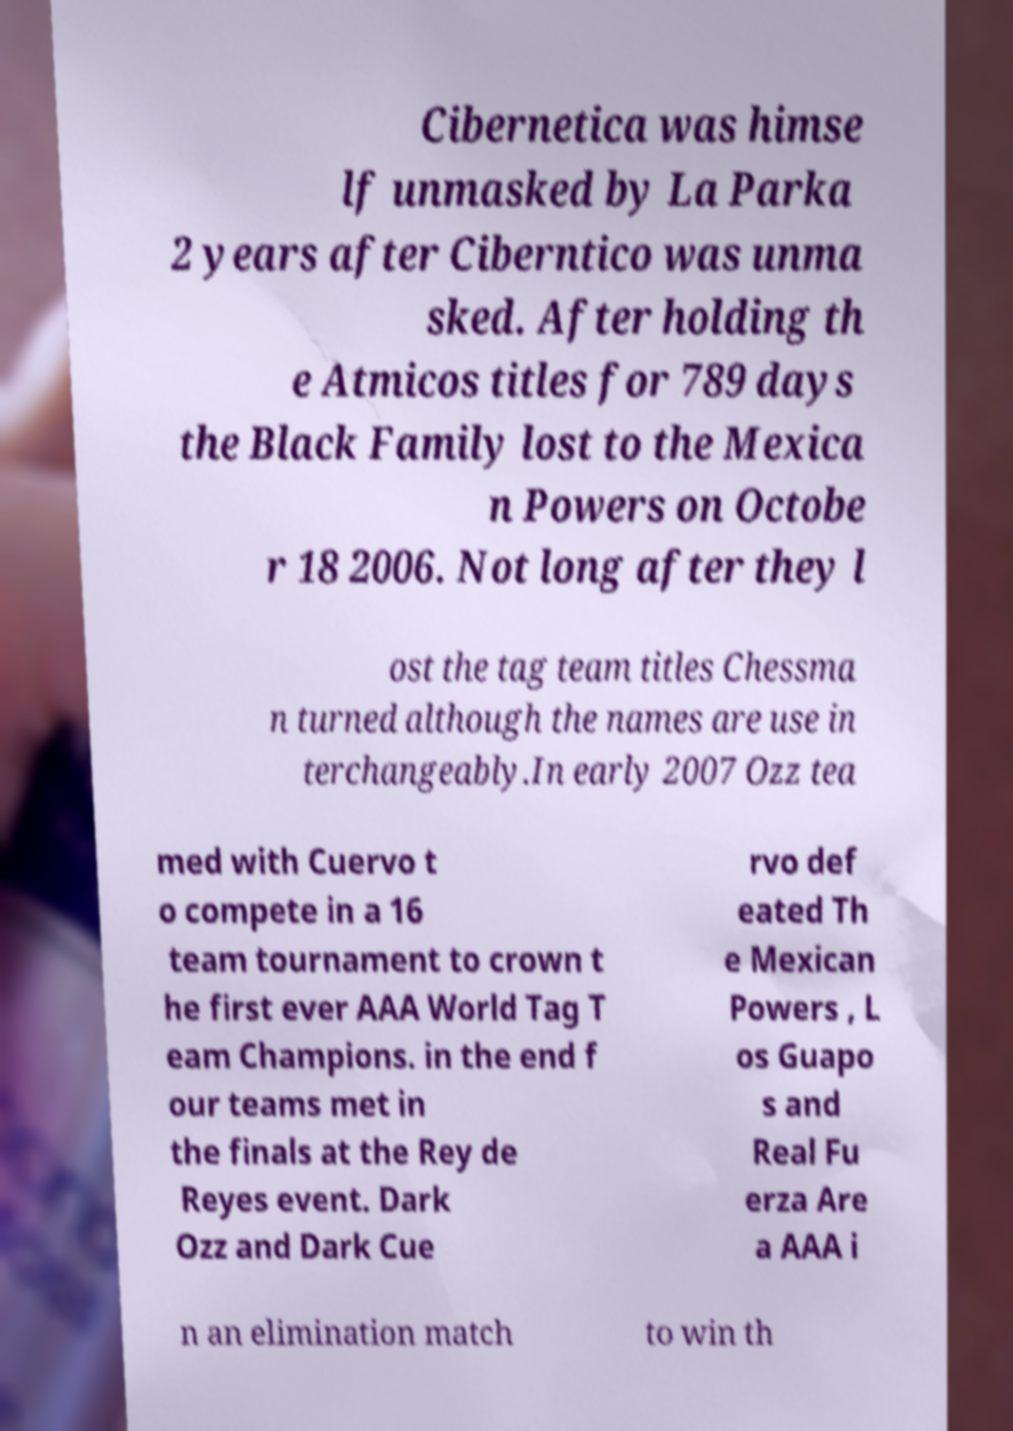Please identify and transcribe the text found in this image. Cibernetica was himse lf unmasked by La Parka 2 years after Ciberntico was unma sked. After holding th e Atmicos titles for 789 days the Black Family lost to the Mexica n Powers on Octobe r 18 2006. Not long after they l ost the tag team titles Chessma n turned although the names are use in terchangeably.In early 2007 Ozz tea med with Cuervo t o compete in a 16 team tournament to crown t he first ever AAA World Tag T eam Champions. in the end f our teams met in the finals at the Rey de Reyes event. Dark Ozz and Dark Cue rvo def eated Th e Mexican Powers , L os Guapo s and Real Fu erza Are a AAA i n an elimination match to win th 